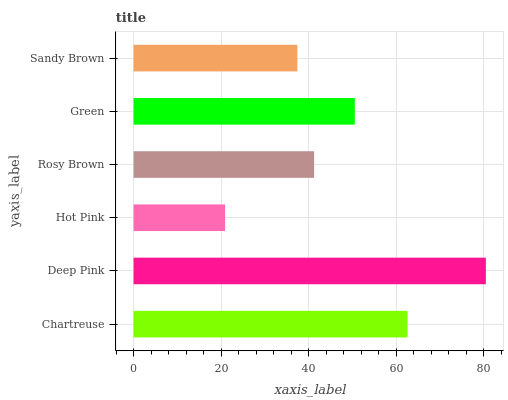Is Hot Pink the minimum?
Answer yes or no. Yes. Is Deep Pink the maximum?
Answer yes or no. Yes. Is Deep Pink the minimum?
Answer yes or no. No. Is Hot Pink the maximum?
Answer yes or no. No. Is Deep Pink greater than Hot Pink?
Answer yes or no. Yes. Is Hot Pink less than Deep Pink?
Answer yes or no. Yes. Is Hot Pink greater than Deep Pink?
Answer yes or no. No. Is Deep Pink less than Hot Pink?
Answer yes or no. No. Is Green the high median?
Answer yes or no. Yes. Is Rosy Brown the low median?
Answer yes or no. Yes. Is Deep Pink the high median?
Answer yes or no. No. Is Sandy Brown the low median?
Answer yes or no. No. 